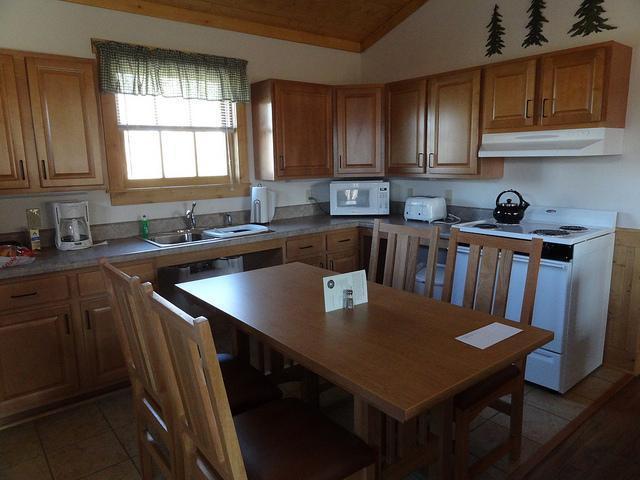How many chairs are there at the table?
Give a very brief answer. 4. How many cabinets are directly above the microwave?
Give a very brief answer. 1. How many chairs in this picture?
Give a very brief answer. 4. How many ovens does this kitchen have?
Give a very brief answer. 1. How many chairs are there?
Give a very brief answer. 6. 